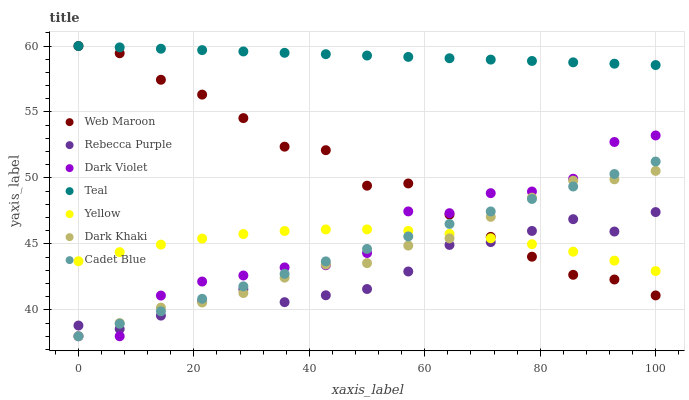Does Rebecca Purple have the minimum area under the curve?
Answer yes or no. Yes. Does Teal have the maximum area under the curve?
Answer yes or no. Yes. Does Dark Violet have the minimum area under the curve?
Answer yes or no. No. Does Dark Violet have the maximum area under the curve?
Answer yes or no. No. Is Cadet Blue the smoothest?
Answer yes or no. Yes. Is Dark Violet the roughest?
Answer yes or no. Yes. Is Web Maroon the smoothest?
Answer yes or no. No. Is Web Maroon the roughest?
Answer yes or no. No. Does Cadet Blue have the lowest value?
Answer yes or no. Yes. Does Web Maroon have the lowest value?
Answer yes or no. No. Does Teal have the highest value?
Answer yes or no. Yes. Does Dark Violet have the highest value?
Answer yes or no. No. Is Rebecca Purple less than Teal?
Answer yes or no. Yes. Is Teal greater than Cadet Blue?
Answer yes or no. Yes. Does Cadet Blue intersect Dark Violet?
Answer yes or no. Yes. Is Cadet Blue less than Dark Violet?
Answer yes or no. No. Is Cadet Blue greater than Dark Violet?
Answer yes or no. No. Does Rebecca Purple intersect Teal?
Answer yes or no. No. 